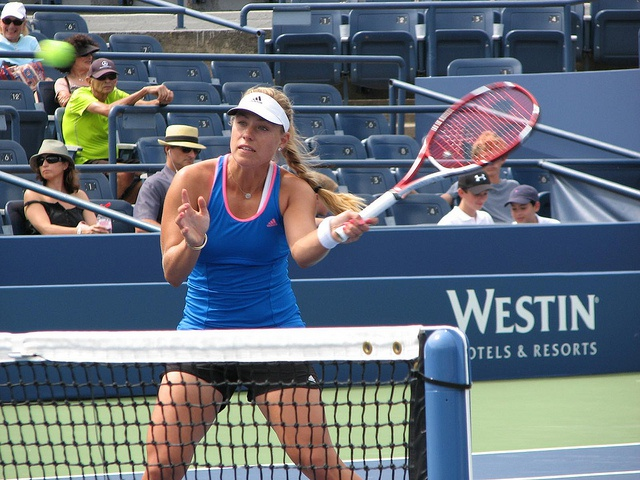Describe the objects in this image and their specific colors. I can see people in darkblue, brown, blue, navy, and black tones, tennis racket in darkblue, white, brown, gray, and lightpink tones, people in darkblue, olive, and gray tones, people in darkblue, black, tan, brown, and lightgray tones, and chair in darkblue, black, navy, and gray tones in this image. 